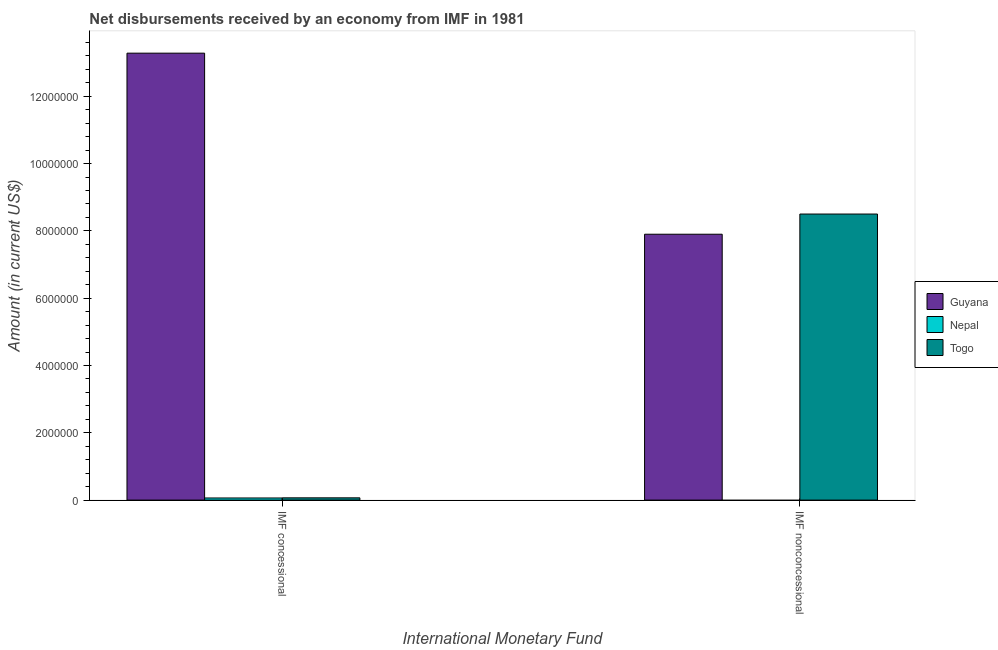How many different coloured bars are there?
Provide a succinct answer. 3. How many groups of bars are there?
Keep it short and to the point. 2. Are the number of bars per tick equal to the number of legend labels?
Your response must be concise. No. How many bars are there on the 1st tick from the left?
Your response must be concise. 3. How many bars are there on the 2nd tick from the right?
Ensure brevity in your answer.  3. What is the label of the 2nd group of bars from the left?
Provide a short and direct response. IMF nonconcessional. What is the net concessional disbursements from imf in Nepal?
Ensure brevity in your answer.  6.30e+04. Across all countries, what is the maximum net concessional disbursements from imf?
Your answer should be very brief. 1.33e+07. Across all countries, what is the minimum net non concessional disbursements from imf?
Give a very brief answer. 0. In which country was the net non concessional disbursements from imf maximum?
Your answer should be very brief. Togo. What is the total net non concessional disbursements from imf in the graph?
Provide a short and direct response. 1.64e+07. What is the difference between the net concessional disbursements from imf in Nepal and that in Guyana?
Your response must be concise. -1.32e+07. What is the difference between the net non concessional disbursements from imf in Nepal and the net concessional disbursements from imf in Guyana?
Make the answer very short. -1.33e+07. What is the average net non concessional disbursements from imf per country?
Keep it short and to the point. 5.47e+06. What is the difference between the net concessional disbursements from imf and net non concessional disbursements from imf in Guyana?
Ensure brevity in your answer.  5.38e+06. What is the ratio of the net concessional disbursements from imf in Guyana to that in Togo?
Offer a very short reply. 198.21. Is the net concessional disbursements from imf in Togo less than that in Nepal?
Provide a short and direct response. No. How many bars are there?
Your answer should be very brief. 5. Are all the bars in the graph horizontal?
Your answer should be compact. No. What is the difference between two consecutive major ticks on the Y-axis?
Make the answer very short. 2.00e+06. Does the graph contain any zero values?
Offer a very short reply. Yes. What is the title of the graph?
Give a very brief answer. Net disbursements received by an economy from IMF in 1981. What is the label or title of the X-axis?
Ensure brevity in your answer.  International Monetary Fund. What is the label or title of the Y-axis?
Offer a terse response. Amount (in current US$). What is the Amount (in current US$) in Guyana in IMF concessional?
Provide a short and direct response. 1.33e+07. What is the Amount (in current US$) in Nepal in IMF concessional?
Your response must be concise. 6.30e+04. What is the Amount (in current US$) in Togo in IMF concessional?
Make the answer very short. 6.70e+04. What is the Amount (in current US$) of Guyana in IMF nonconcessional?
Give a very brief answer. 7.90e+06. What is the Amount (in current US$) of Nepal in IMF nonconcessional?
Provide a short and direct response. 0. What is the Amount (in current US$) in Togo in IMF nonconcessional?
Your answer should be very brief. 8.50e+06. Across all International Monetary Fund, what is the maximum Amount (in current US$) in Guyana?
Offer a terse response. 1.33e+07. Across all International Monetary Fund, what is the maximum Amount (in current US$) in Nepal?
Provide a succinct answer. 6.30e+04. Across all International Monetary Fund, what is the maximum Amount (in current US$) in Togo?
Offer a very short reply. 8.50e+06. Across all International Monetary Fund, what is the minimum Amount (in current US$) of Guyana?
Provide a short and direct response. 7.90e+06. Across all International Monetary Fund, what is the minimum Amount (in current US$) in Nepal?
Your response must be concise. 0. Across all International Monetary Fund, what is the minimum Amount (in current US$) in Togo?
Offer a terse response. 6.70e+04. What is the total Amount (in current US$) of Guyana in the graph?
Your answer should be very brief. 2.12e+07. What is the total Amount (in current US$) of Nepal in the graph?
Ensure brevity in your answer.  6.30e+04. What is the total Amount (in current US$) of Togo in the graph?
Make the answer very short. 8.57e+06. What is the difference between the Amount (in current US$) in Guyana in IMF concessional and that in IMF nonconcessional?
Provide a succinct answer. 5.38e+06. What is the difference between the Amount (in current US$) of Togo in IMF concessional and that in IMF nonconcessional?
Ensure brevity in your answer.  -8.43e+06. What is the difference between the Amount (in current US$) in Guyana in IMF concessional and the Amount (in current US$) in Togo in IMF nonconcessional?
Your answer should be very brief. 4.78e+06. What is the difference between the Amount (in current US$) of Nepal in IMF concessional and the Amount (in current US$) of Togo in IMF nonconcessional?
Your response must be concise. -8.44e+06. What is the average Amount (in current US$) in Guyana per International Monetary Fund?
Offer a very short reply. 1.06e+07. What is the average Amount (in current US$) in Nepal per International Monetary Fund?
Your answer should be compact. 3.15e+04. What is the average Amount (in current US$) in Togo per International Monetary Fund?
Your answer should be compact. 4.28e+06. What is the difference between the Amount (in current US$) in Guyana and Amount (in current US$) in Nepal in IMF concessional?
Make the answer very short. 1.32e+07. What is the difference between the Amount (in current US$) in Guyana and Amount (in current US$) in Togo in IMF concessional?
Offer a very short reply. 1.32e+07. What is the difference between the Amount (in current US$) of Nepal and Amount (in current US$) of Togo in IMF concessional?
Offer a terse response. -4000. What is the difference between the Amount (in current US$) in Guyana and Amount (in current US$) in Togo in IMF nonconcessional?
Keep it short and to the point. -6.00e+05. What is the ratio of the Amount (in current US$) in Guyana in IMF concessional to that in IMF nonconcessional?
Your answer should be compact. 1.68. What is the ratio of the Amount (in current US$) in Togo in IMF concessional to that in IMF nonconcessional?
Make the answer very short. 0.01. What is the difference between the highest and the second highest Amount (in current US$) in Guyana?
Your answer should be compact. 5.38e+06. What is the difference between the highest and the second highest Amount (in current US$) in Togo?
Offer a very short reply. 8.43e+06. What is the difference between the highest and the lowest Amount (in current US$) in Guyana?
Provide a succinct answer. 5.38e+06. What is the difference between the highest and the lowest Amount (in current US$) of Nepal?
Ensure brevity in your answer.  6.30e+04. What is the difference between the highest and the lowest Amount (in current US$) of Togo?
Your answer should be compact. 8.43e+06. 